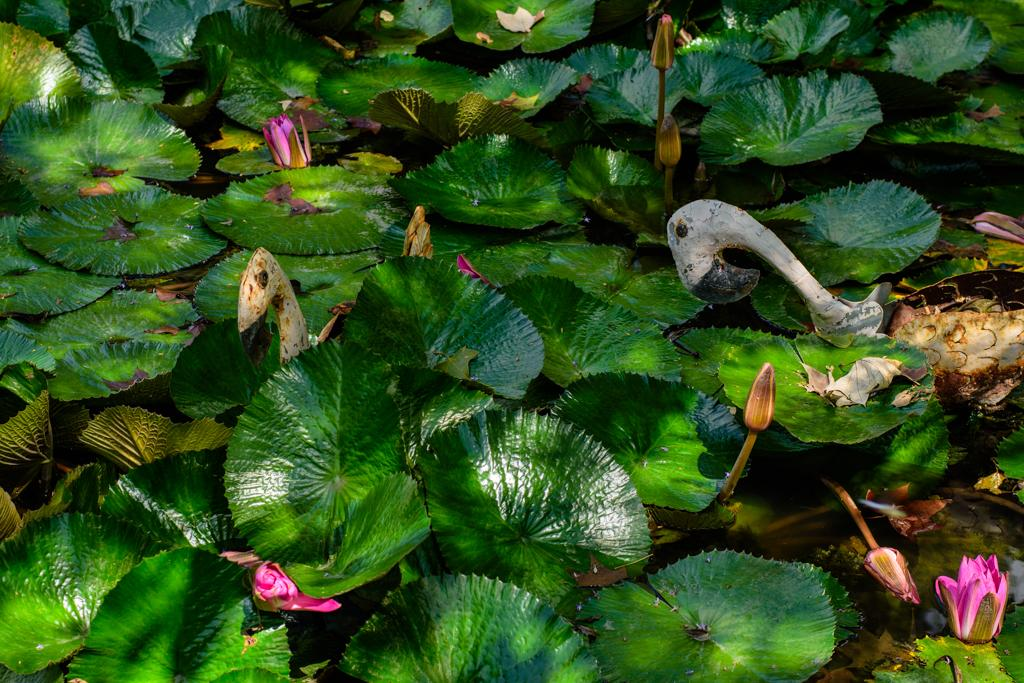What type of plant material can be seen in the image? There are leaves in the image. What stage of plant growth is depicted in the image? There are buds in the image. What type of animals are present in the image? There are birds in the image. What natural element is visible in the image? There is water visible in the image. What type of quiver can be seen in the image? There is no quiver present in the image. How many beetles are visible in the image? There are no beetles visible in the image. 